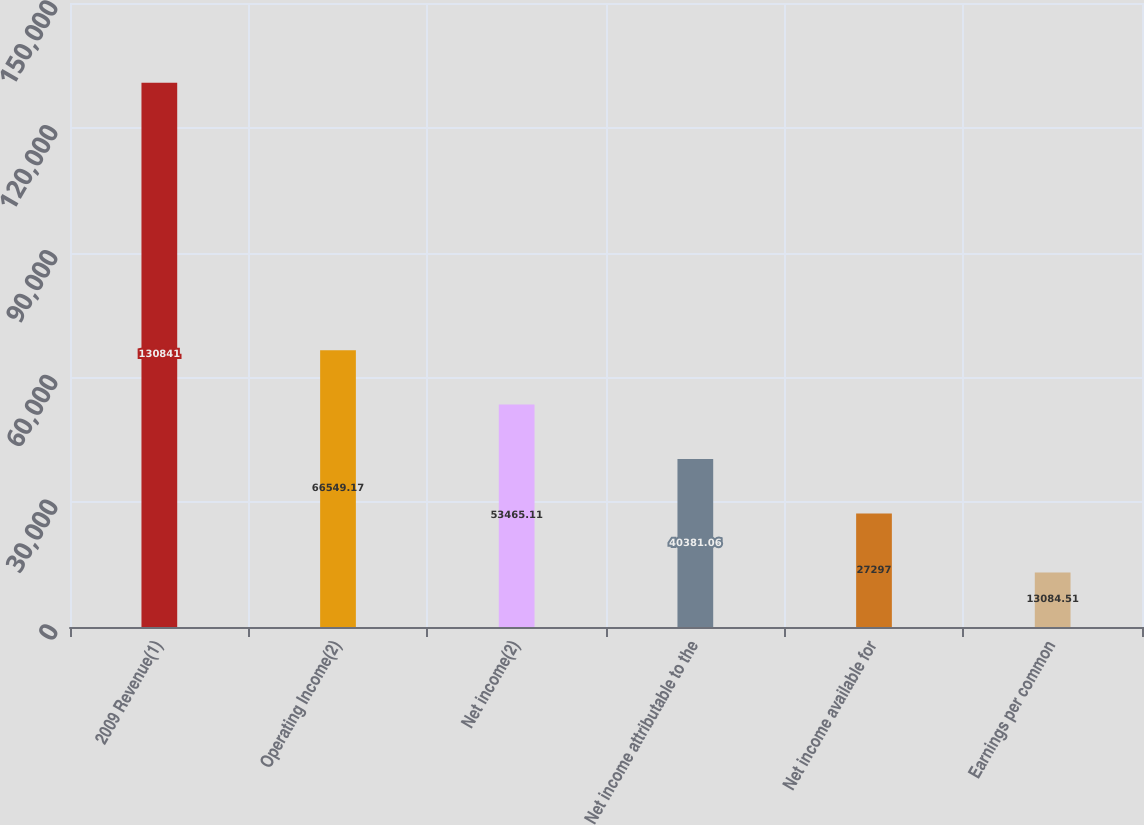<chart> <loc_0><loc_0><loc_500><loc_500><bar_chart><fcel>2009 Revenue(1)<fcel>Operating Income(2)<fcel>Net income(2)<fcel>Net income attributable to the<fcel>Net income available for<fcel>Earnings per common<nl><fcel>130841<fcel>66549.2<fcel>53465.1<fcel>40381.1<fcel>27297<fcel>13084.5<nl></chart> 